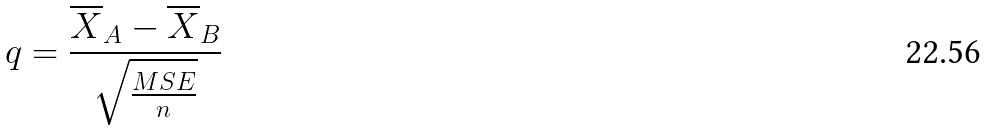Convert formula to latex. <formula><loc_0><loc_0><loc_500><loc_500>q = \frac { \overline { X } _ { A } - \overline { X } _ { B } } { \sqrt { \frac { M S E } { n } } }</formula> 